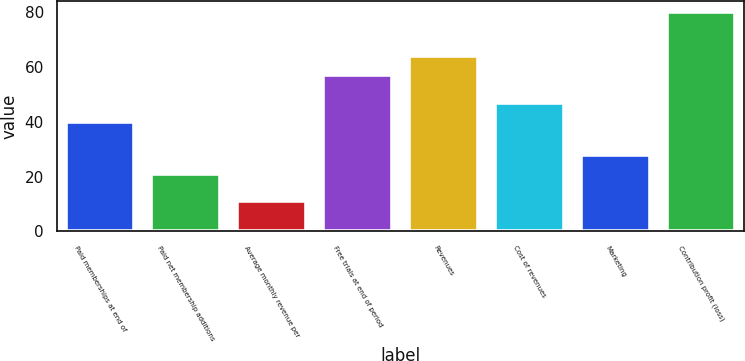<chart> <loc_0><loc_0><loc_500><loc_500><bar_chart><fcel>Paid memberships at end of<fcel>Paid net membership additions<fcel>Average monthly revenue per<fcel>Free trials at end of period<fcel>Revenues<fcel>Cost of revenues<fcel>Marketing<fcel>Contribution profit (loss)<nl><fcel>40<fcel>21<fcel>11<fcel>57<fcel>63.9<fcel>46.9<fcel>27.9<fcel>80<nl></chart> 